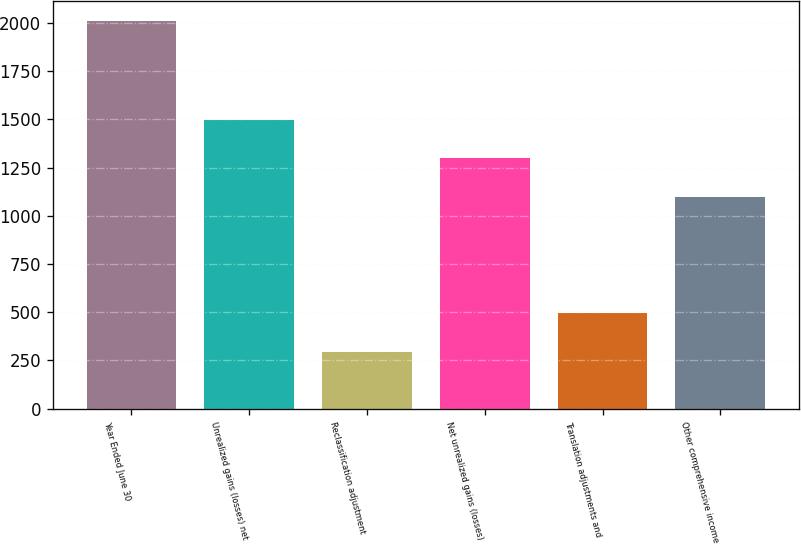Convert chart to OTSL. <chart><loc_0><loc_0><loc_500><loc_500><bar_chart><fcel>Year Ended June 30<fcel>Unrealized gains (losses) net<fcel>Reclassification adjustment<fcel>Net unrealized gains (losses)<fcel>Translation adjustments and<fcel>Other comprehensive income<nl><fcel>2011<fcel>1498.6<fcel>295<fcel>1298<fcel>495.6<fcel>1097.4<nl></chart> 